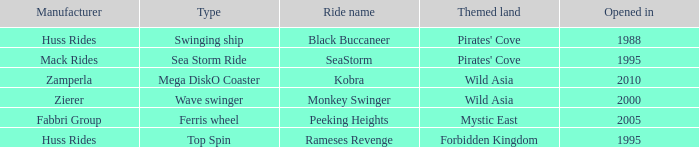What ride was manufactured by Zierer? Monkey Swinger. 